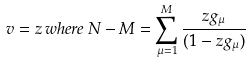<formula> <loc_0><loc_0><loc_500><loc_500>v = z \, w h e r e \, N - M = \sum _ { \mu = 1 } ^ { M } \frac { z g _ { \mu } } { ( 1 - z g _ { \mu } ) }</formula> 